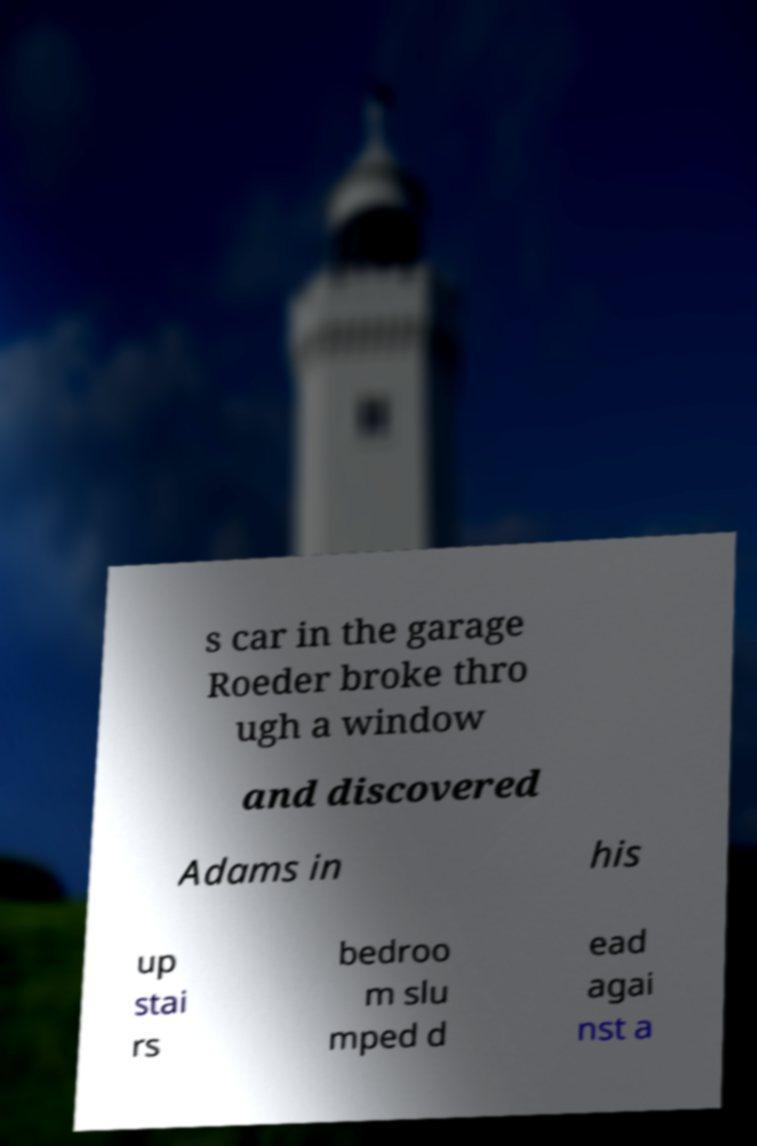What messages or text are displayed in this image? I need them in a readable, typed format. s car in the garage Roeder broke thro ugh a window and discovered Adams in his up stai rs bedroo m slu mped d ead agai nst a 